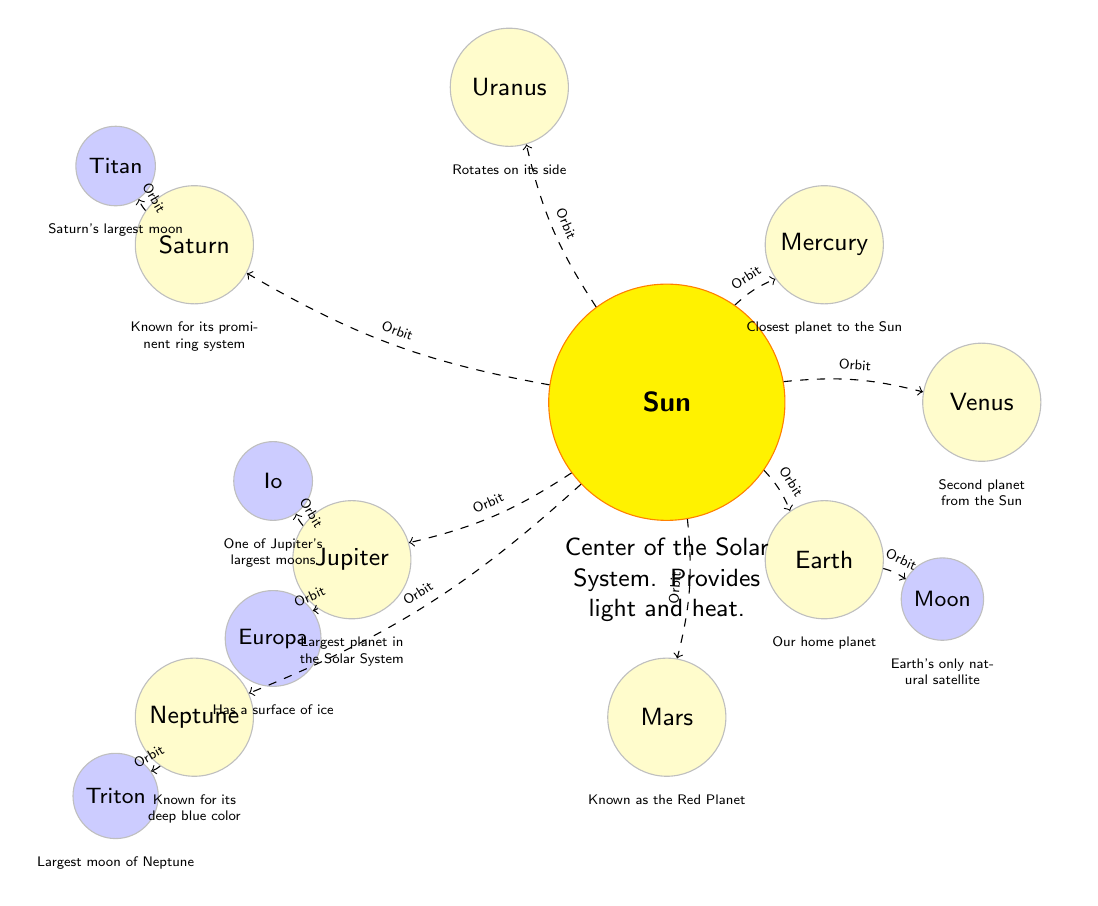What is the largest planet in the Solar System? The diagram indicates that Jupiter is identified as "Largest planet in the Solar System" with the corresponding label beneath it.
Answer: Jupiter Which planet is known as the Red Planet? The diagram specifies Mars as "Known as the Red Planet," distinguishing it from the other planets.
Answer: Mars How many moons are associated with Jupiter in the diagram? The diagram shows two moons connected to Jupiter: Io and Europa. Counting these moons reveals the total as two.
Answer: 2 What is the only natural satellite of Earth mentioned in the diagram? The diagram specifically labels the Moon as "Earth's only natural satellite," clearly highlighting its relationship to Earth.
Answer: Moon Which planet rotates on its side? Uranus is described in the diagram as "Rotates on its side," indicating its unique axial tilt compared to other planets.
Answer: Uranus What is at the center of the Solar System? The diagram identifies the Sun as the center of the Solar System, with the description emphasizing its role in providing light and heat.
Answer: Sun Which planet is the closest to the Sun? According to the diagram, Mercury is mentioned as "Closest planet to the Sun," making it clear which planet this refers to.
Answer: Mercury How many outer planets are shown in the diagram? The outer planets identified in the diagram are Jupiter, Saturn, Uranus, and Neptune, giving us a total of four outer planets.
Answer: 4 Which planet has a prominent ring system? The diagram specifically states that Saturn is "Known for its prominent ring system," differentiating it from the other planets.
Answer: Saturn 